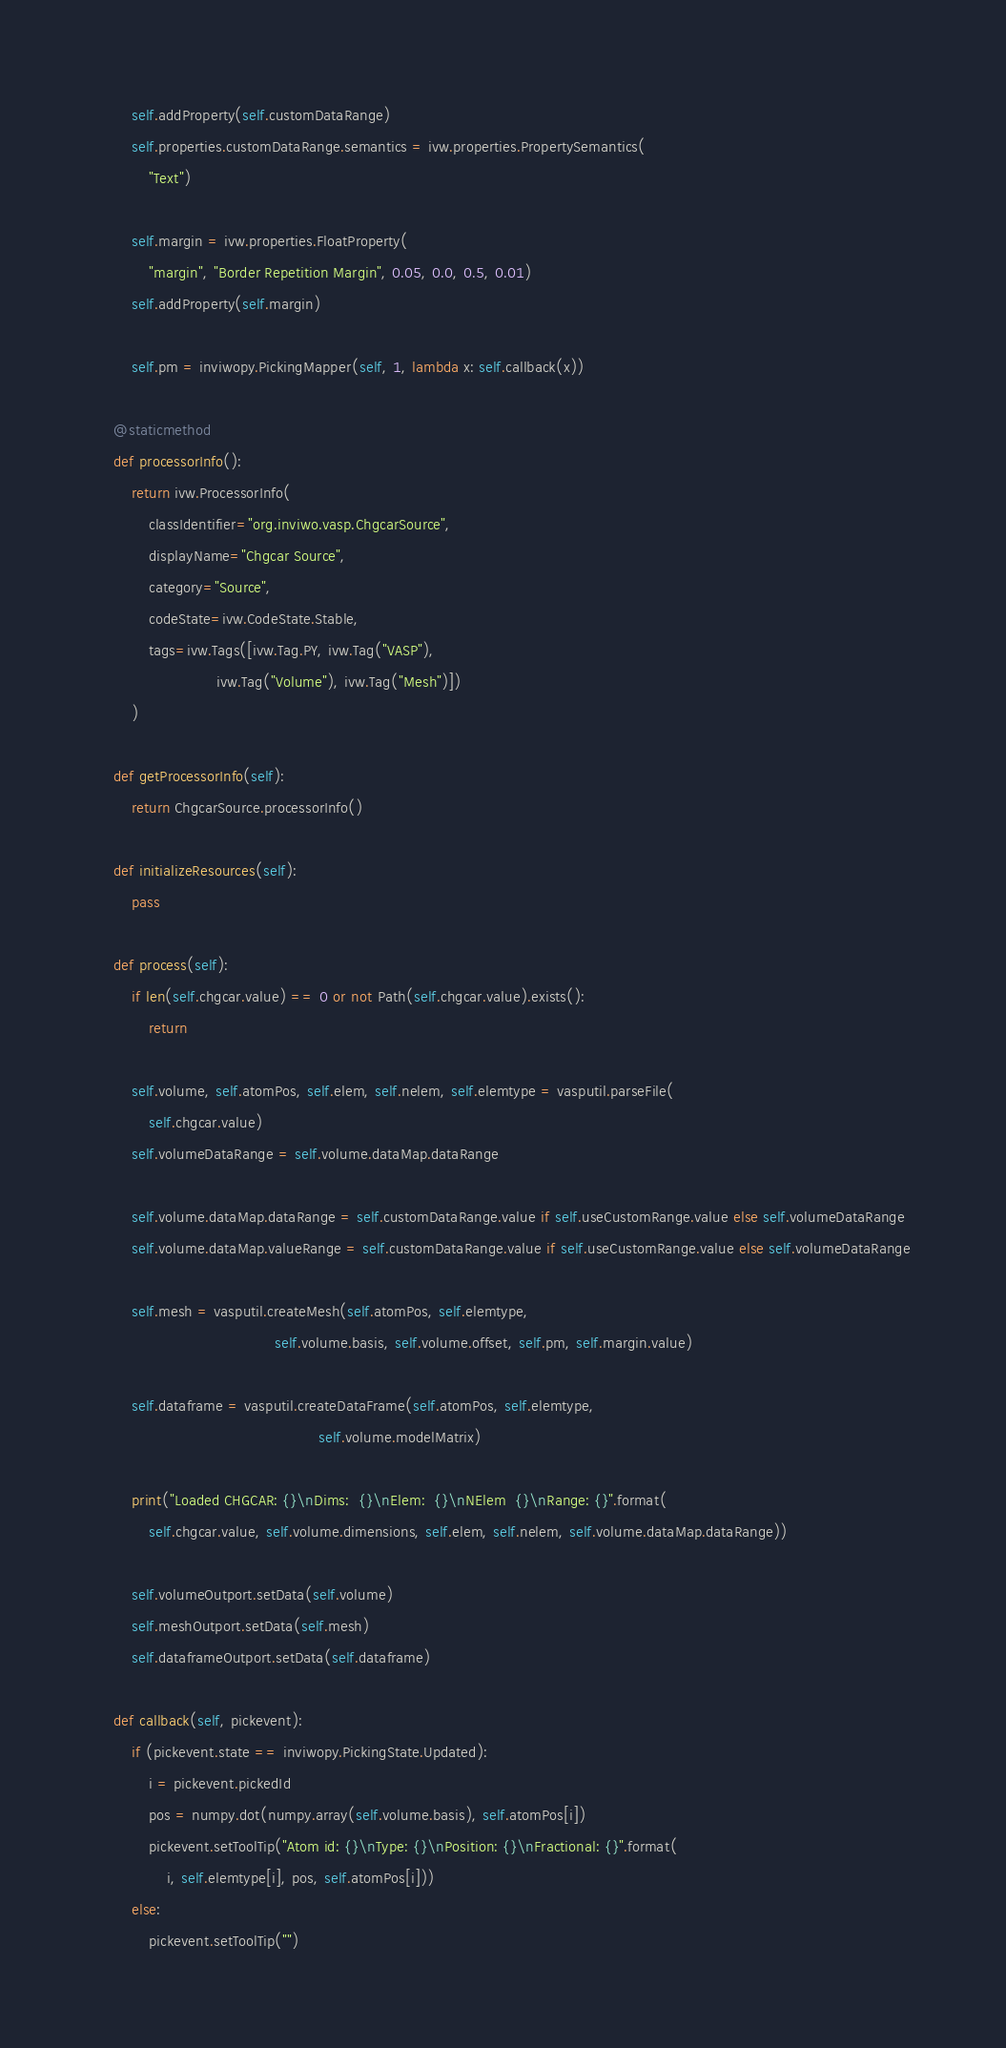<code> <loc_0><loc_0><loc_500><loc_500><_Python_>        self.addProperty(self.customDataRange)
        self.properties.customDataRange.semantics = ivw.properties.PropertySemantics(
            "Text")

        self.margin = ivw.properties.FloatProperty(
            "margin", "Border Repetition Margin", 0.05, 0.0, 0.5, 0.01)
        self.addProperty(self.margin)

        self.pm = inviwopy.PickingMapper(self, 1, lambda x: self.callback(x))

    @staticmethod
    def processorInfo():
        return ivw.ProcessorInfo(
            classIdentifier="org.inviwo.vasp.ChgcarSource",
            displayName="Chgcar Source",
            category="Source",
            codeState=ivw.CodeState.Stable,
            tags=ivw.Tags([ivw.Tag.PY, ivw.Tag("VASP"),
                           ivw.Tag("Volume"), ivw.Tag("Mesh")])
        )

    def getProcessorInfo(self):
        return ChgcarSource.processorInfo()

    def initializeResources(self):
        pass

    def process(self):
        if len(self.chgcar.value) == 0 or not Path(self.chgcar.value).exists():
            return

        self.volume, self.atomPos, self.elem, self.nelem, self.elemtype = vasputil.parseFile(
            self.chgcar.value)
        self.volumeDataRange = self.volume.dataMap.dataRange

        self.volume.dataMap.dataRange = self.customDataRange.value if self.useCustomRange.value else self.volumeDataRange
        self.volume.dataMap.valueRange = self.customDataRange.value if self.useCustomRange.value else self.volumeDataRange

        self.mesh = vasputil.createMesh(self.atomPos, self.elemtype,
                                        self.volume.basis, self.volume.offset, self.pm, self.margin.value)

        self.dataframe = vasputil.createDataFrame(self.atomPos, self.elemtype,
                                                  self.volume.modelMatrix)

        print("Loaded CHGCAR: {}\nDims:  {}\nElem:  {}\nNElem  {}\nRange: {}".format(
            self.chgcar.value, self.volume.dimensions, self.elem, self.nelem, self.volume.dataMap.dataRange))

        self.volumeOutport.setData(self.volume)
        self.meshOutport.setData(self.mesh)
        self.dataframeOutport.setData(self.dataframe)

    def callback(self, pickevent):
        if (pickevent.state == inviwopy.PickingState.Updated):
            i = pickevent.pickedId
            pos = numpy.dot(numpy.array(self.volume.basis), self.atomPos[i])
            pickevent.setToolTip("Atom id: {}\nType: {}\nPosition: {}\nFractional: {}".format(
                i, self.elemtype[i], pos, self.atomPos[i]))
        else:
            pickevent.setToolTip("")
</code> 